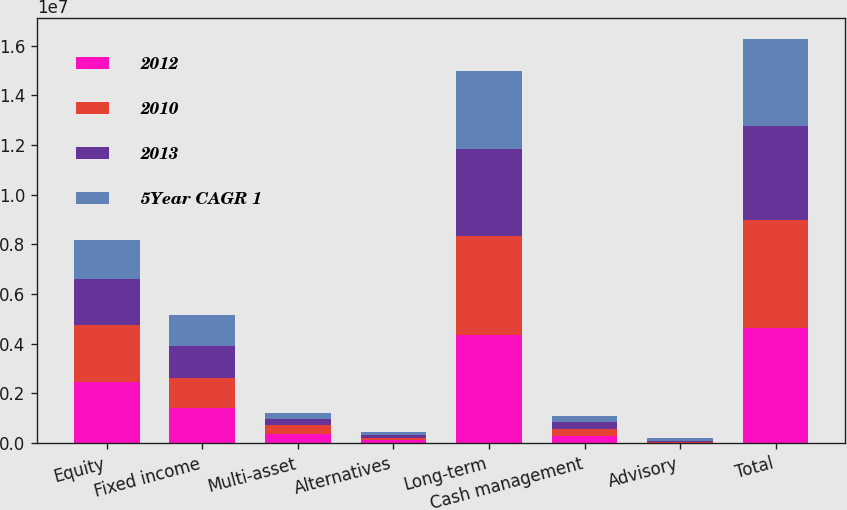Convert chart. <chart><loc_0><loc_0><loc_500><loc_500><stacked_bar_chart><ecel><fcel>Equity<fcel>Fixed income<fcel>Multi-asset<fcel>Alternatives<fcel>Long-term<fcel>Cash management<fcel>Advisory<fcel>Total<nl><fcel>2012<fcel>2.45111e+06<fcel>1.39365e+06<fcel>377837<fcel>111240<fcel>4.33384e+06<fcel>296353<fcel>21701<fcel>4.6519e+06<nl><fcel>2010<fcel>2.3177e+06<fcel>1.24219e+06<fcel>341214<fcel>111114<fcel>4.01221e+06<fcel>275554<fcel>36325<fcel>4.32409e+06<nl><fcel>2013<fcel>1.8455e+06<fcel>1.25932e+06<fcel>267748<fcel>109795<fcel>3.48237e+06<fcel>263743<fcel>45479<fcel>3.79159e+06<nl><fcel>5Year CAGR 1<fcel>1.56011e+06<fcel>1.24772e+06<fcel>225170<fcel>104948<fcel>3.13795e+06<fcel>254665<fcel>120070<fcel>3.51268e+06<nl></chart> 